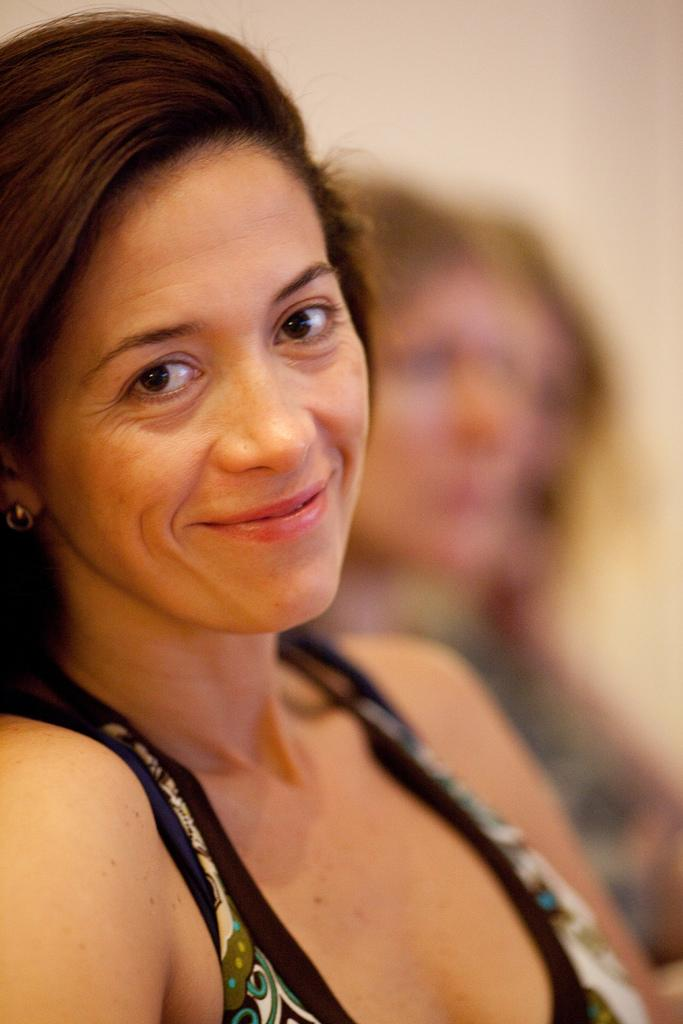Who is the main subject in the image? There is a woman in the image. What is the woman doing in the image? The woman is smiling. Can you describe the background of the image? The background of the image is blurry. Are there any other people visible in the image? Yes, there are people visible in the background. What can be seen behind the people in the background? There is a wall in the background. What type of motion can be seen in the image? There is no motion visible in the image; it appears to be a still photograph. 